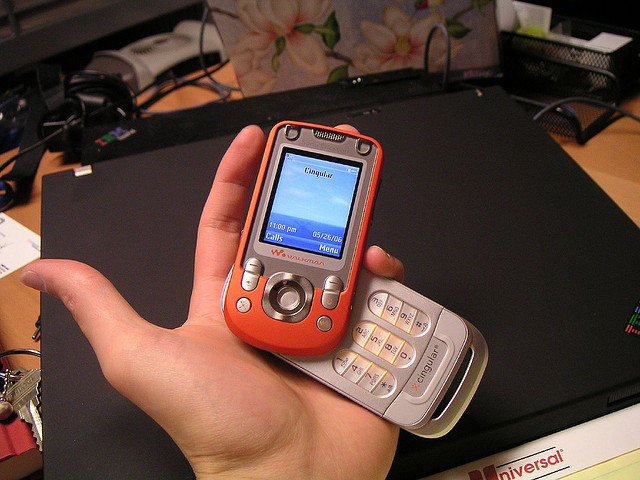<image>What brand of laptop is in the photo? The brand of laptop in the photo is uncertain. It might be 'ibm', 'universal' or 'cingular'. What brand of laptop is in the photo? I am not sure what brand of laptop is in the photo. However, it can be seen 'ibm' or 'cingular'. 